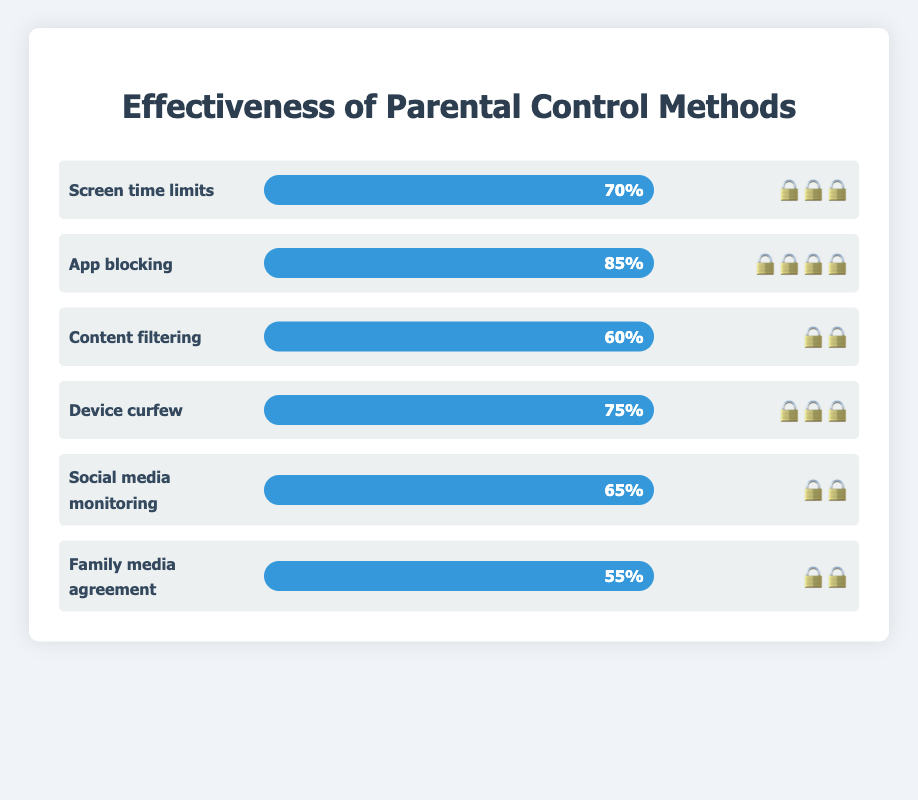What is the title of the figure? The title is located at the top center of the figure. It reads, "Effectiveness of Parental Control Methods."
Answer: Effectiveness of Parental Control Methods How many parental control methods are displayed in the figure? Counting all the different parental control methods listed vertically in the chart reveals there are six methods.
Answer: Six Which parental control method has the highest effectiveness? Look at the effectiveness bars to compare their lengths. The longest bar corresponds to "App blocking," with an effectiveness of 85%.
Answer: App blocking What is the effectiveness percentage of device curfew? Finding "Device curfew" in the list, you can then look at the effectiveness bar. It is labeled with "75%."
Answer: 75% How many lock emojis does the "Content filtering" method have? Find "Content filtering" in the list and count the lock emojis next to it. There are two lock emojis.
Answer: 2 Which method is less effective: Social media monitoring or Family media agreement? Compare the effectiveness percentages of both methods. Social media monitoring has 65%, while Family media agreement has 55%. Therefore, Family media agreement is less effective.
Answer: Family media agreement What is the combined effectiveness of Screen time limits and Content filtering? Add the effectiveness percentages of "Screen time limits" (70%) and "Content filtering" (60%). The sum is 70 + 60 = 130%.
Answer: 130% Which methods have exactly three lock emojis? Count the lock emojis for each method. "Screen time limits," "Device curfew," and "Content filtering" have exactly three lock emojis.
Answer: Screen time limits, Device curfew, Content filtering What is the difference in effectiveness between App blocking and Family media agreement? Subtract the effectiveness percentage of "Family media agreement" (55%) from that of "App blocking" (85%). The difference is 85 - 55 = 30%.
Answer: 30% Rank the parental control methods from most effective to least effective. Evaluate each method's effectiveness percentage and order them from highest to lowest. The ranking is: App blocking (85%), Device curfew (75%), Screen time limits (70%), Social media monitoring (65%), Content filtering (60%), Family media agreement (55%).
Answer: App blocking, Device curfew, Screen time limits, Social media monitoring, Content filtering, Family media agreement 